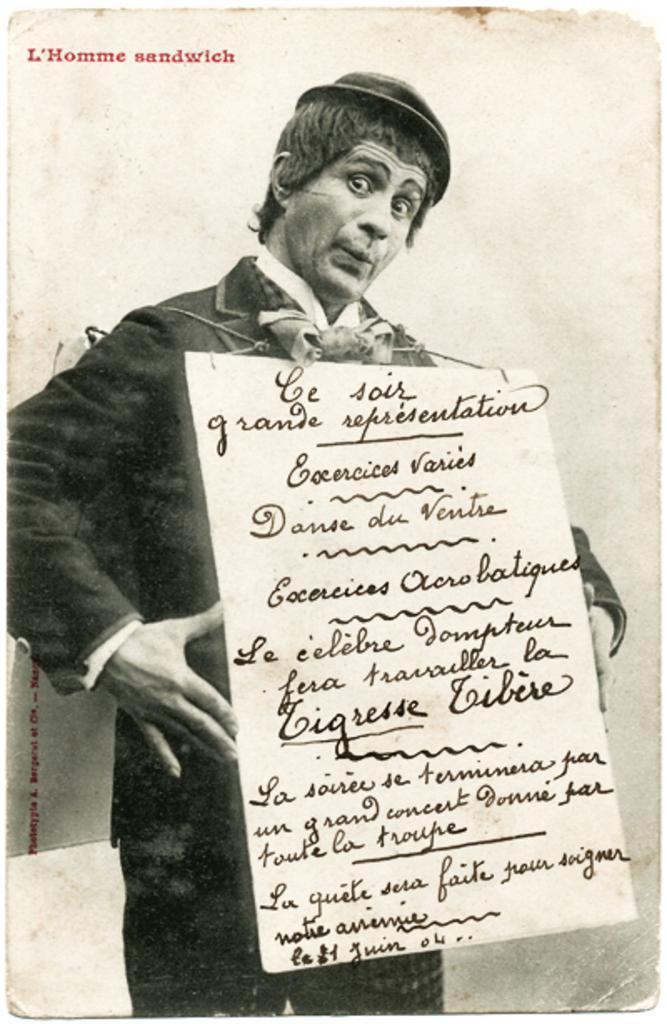Can you describe this image briefly? In this image we can see black and white picture of a person holding a board with some text on it. 